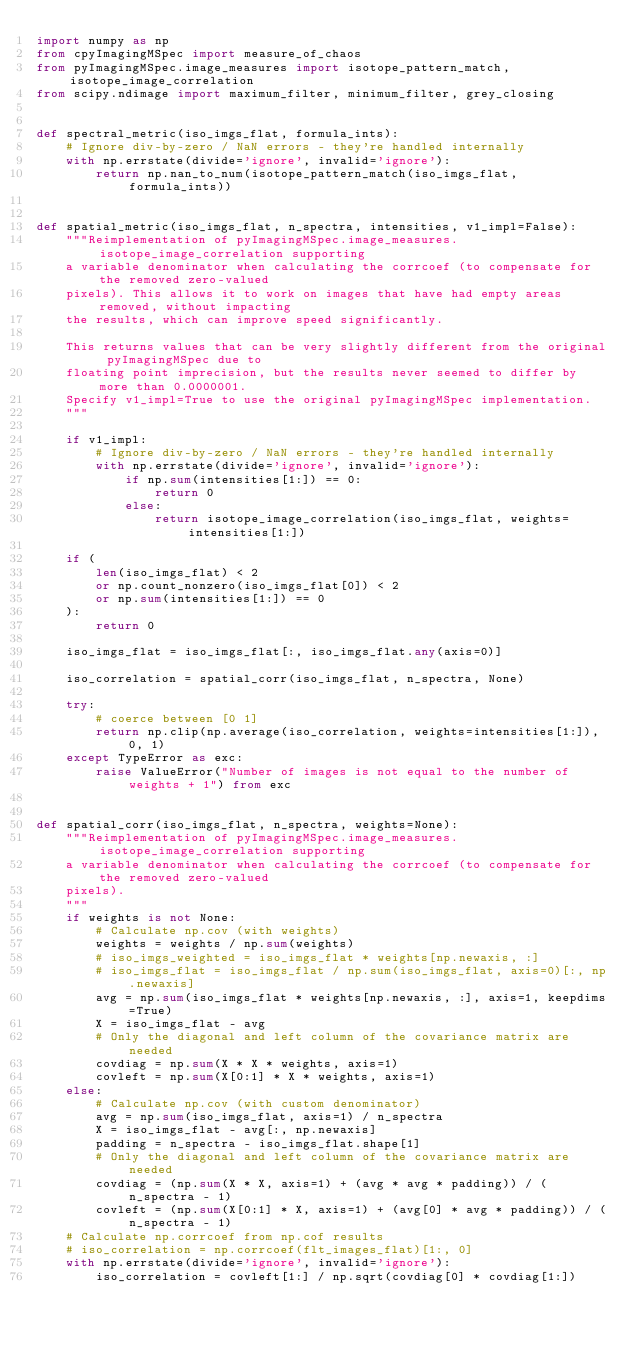<code> <loc_0><loc_0><loc_500><loc_500><_Python_>import numpy as np
from cpyImagingMSpec import measure_of_chaos
from pyImagingMSpec.image_measures import isotope_pattern_match, isotope_image_correlation
from scipy.ndimage import maximum_filter, minimum_filter, grey_closing


def spectral_metric(iso_imgs_flat, formula_ints):
    # Ignore div-by-zero / NaN errors - they're handled internally
    with np.errstate(divide='ignore', invalid='ignore'):
        return np.nan_to_num(isotope_pattern_match(iso_imgs_flat, formula_ints))


def spatial_metric(iso_imgs_flat, n_spectra, intensities, v1_impl=False):
    """Reimplementation of pyImagingMSpec.image_measures.isotope_image_correlation supporting
    a variable denominator when calculating the corrcoef (to compensate for the removed zero-valued
    pixels). This allows it to work on images that have had empty areas removed, without impacting
    the results, which can improve speed significantly.

    This returns values that can be very slightly different from the original pyImagingMSpec due to
    floating point imprecision, but the results never seemed to differ by more than 0.0000001.
    Specify v1_impl=True to use the original pyImagingMSpec implementation.
    """

    if v1_impl:
        # Ignore div-by-zero / NaN errors - they're handled internally
        with np.errstate(divide='ignore', invalid='ignore'):
            if np.sum(intensities[1:]) == 0:
                return 0
            else:
                return isotope_image_correlation(iso_imgs_flat, weights=intensities[1:])

    if (
        len(iso_imgs_flat) < 2
        or np.count_nonzero(iso_imgs_flat[0]) < 2
        or np.sum(intensities[1:]) == 0
    ):
        return 0

    iso_imgs_flat = iso_imgs_flat[:, iso_imgs_flat.any(axis=0)]

    iso_correlation = spatial_corr(iso_imgs_flat, n_spectra, None)

    try:
        # coerce between [0 1]
        return np.clip(np.average(iso_correlation, weights=intensities[1:]), 0, 1)
    except TypeError as exc:
        raise ValueError("Number of images is not equal to the number of weights + 1") from exc


def spatial_corr(iso_imgs_flat, n_spectra, weights=None):
    """Reimplementation of pyImagingMSpec.image_measures.isotope_image_correlation supporting
    a variable denominator when calculating the corrcoef (to compensate for the removed zero-valued
    pixels).
    """
    if weights is not None:
        # Calculate np.cov (with weights)
        weights = weights / np.sum(weights)
        # iso_imgs_weighted = iso_imgs_flat * weights[np.newaxis, :]
        # iso_imgs_flat = iso_imgs_flat / np.sum(iso_imgs_flat, axis=0)[:, np.newaxis]
        avg = np.sum(iso_imgs_flat * weights[np.newaxis, :], axis=1, keepdims=True)
        X = iso_imgs_flat - avg
        # Only the diagonal and left column of the covariance matrix are needed
        covdiag = np.sum(X * X * weights, axis=1)
        covleft = np.sum(X[0:1] * X * weights, axis=1)
    else:
        # Calculate np.cov (with custom denominator)
        avg = np.sum(iso_imgs_flat, axis=1) / n_spectra
        X = iso_imgs_flat - avg[:, np.newaxis]
        padding = n_spectra - iso_imgs_flat.shape[1]
        # Only the diagonal and left column of the covariance matrix are needed
        covdiag = (np.sum(X * X, axis=1) + (avg * avg * padding)) / (n_spectra - 1)
        covleft = (np.sum(X[0:1] * X, axis=1) + (avg[0] * avg * padding)) / (n_spectra - 1)
    # Calculate np.corrcoef from np.cof results
    # iso_correlation = np.corrcoef(flt_images_flat)[1:, 0]
    with np.errstate(divide='ignore', invalid='ignore'):
        iso_correlation = covleft[1:] / np.sqrt(covdiag[0] * covdiag[1:])</code> 